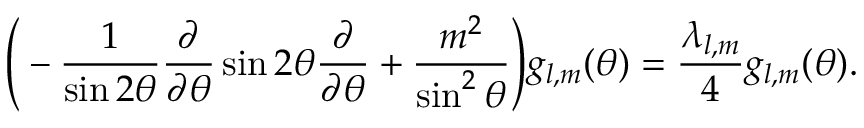<formula> <loc_0><loc_0><loc_500><loc_500>\left ( - \frac { 1 } { \sin { 2 \theta } } \frac { \partial } { \partial \theta } \sin { 2 \theta } \frac { \partial } { \partial \theta } + \frac { m ^ { 2 } } { \sin ^ { 2 } { \theta } } \right ) g _ { l , m } ( \theta ) = \frac { \lambda _ { l , m } } { 4 } g _ { l , m } ( \theta ) .</formula> 